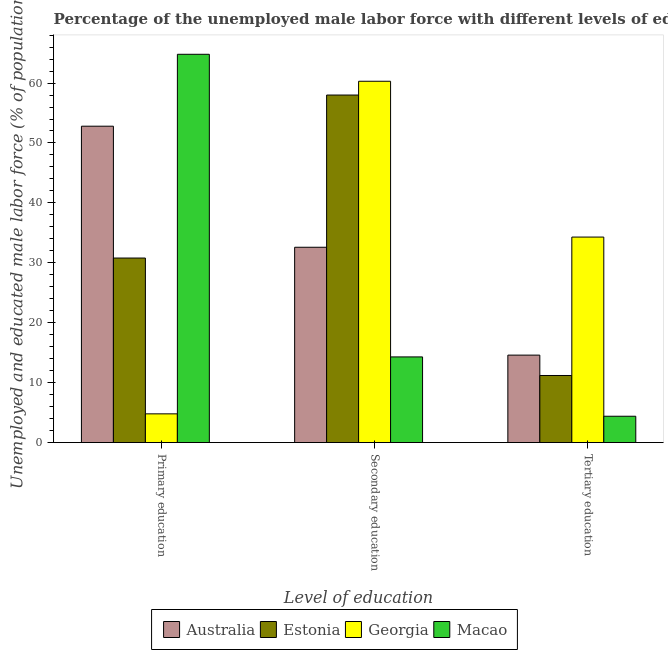How many different coloured bars are there?
Your answer should be compact. 4. Are the number of bars per tick equal to the number of legend labels?
Offer a very short reply. Yes. What is the label of the 2nd group of bars from the left?
Your answer should be very brief. Secondary education. What is the percentage of male labor force who received primary education in Macao?
Your response must be concise. 64.8. Across all countries, what is the maximum percentage of male labor force who received primary education?
Your response must be concise. 64.8. Across all countries, what is the minimum percentage of male labor force who received tertiary education?
Make the answer very short. 4.4. In which country was the percentage of male labor force who received tertiary education maximum?
Keep it short and to the point. Georgia. In which country was the percentage of male labor force who received tertiary education minimum?
Ensure brevity in your answer.  Macao. What is the total percentage of male labor force who received secondary education in the graph?
Keep it short and to the point. 165.2. What is the difference between the percentage of male labor force who received secondary education in Macao and that in Georgia?
Offer a very short reply. -46. What is the difference between the percentage of male labor force who received primary education in Georgia and the percentage of male labor force who received tertiary education in Macao?
Your response must be concise. 0.4. What is the average percentage of male labor force who received tertiary education per country?
Offer a very short reply. 16.12. What is the difference between the percentage of male labor force who received primary education and percentage of male labor force who received tertiary education in Georgia?
Offer a very short reply. -29.5. In how many countries, is the percentage of male labor force who received primary education greater than 40 %?
Give a very brief answer. 2. What is the ratio of the percentage of male labor force who received primary education in Estonia to that in Georgia?
Ensure brevity in your answer.  6.42. Is the difference between the percentage of male labor force who received primary education in Georgia and Macao greater than the difference between the percentage of male labor force who received tertiary education in Georgia and Macao?
Keep it short and to the point. No. What is the difference between the highest and the second highest percentage of male labor force who received secondary education?
Your answer should be very brief. 2.3. What is the difference between the highest and the lowest percentage of male labor force who received primary education?
Offer a terse response. 60. What does the 3rd bar from the left in Tertiary education represents?
Make the answer very short. Georgia. What does the 3rd bar from the right in Primary education represents?
Your answer should be compact. Estonia. Is it the case that in every country, the sum of the percentage of male labor force who received primary education and percentage of male labor force who received secondary education is greater than the percentage of male labor force who received tertiary education?
Make the answer very short. Yes. How many countries are there in the graph?
Make the answer very short. 4. What is the difference between two consecutive major ticks on the Y-axis?
Your answer should be very brief. 10. Are the values on the major ticks of Y-axis written in scientific E-notation?
Keep it short and to the point. No. Does the graph contain any zero values?
Make the answer very short. No. Where does the legend appear in the graph?
Your response must be concise. Bottom center. How many legend labels are there?
Make the answer very short. 4. What is the title of the graph?
Ensure brevity in your answer.  Percentage of the unemployed male labor force with different levels of education in countries. Does "Low income" appear as one of the legend labels in the graph?
Give a very brief answer. No. What is the label or title of the X-axis?
Provide a succinct answer. Level of education. What is the label or title of the Y-axis?
Provide a succinct answer. Unemployed and educated male labor force (% of population). What is the Unemployed and educated male labor force (% of population) of Australia in Primary education?
Offer a very short reply. 52.8. What is the Unemployed and educated male labor force (% of population) in Estonia in Primary education?
Offer a very short reply. 30.8. What is the Unemployed and educated male labor force (% of population) of Georgia in Primary education?
Your response must be concise. 4.8. What is the Unemployed and educated male labor force (% of population) of Macao in Primary education?
Offer a terse response. 64.8. What is the Unemployed and educated male labor force (% of population) in Australia in Secondary education?
Provide a short and direct response. 32.6. What is the Unemployed and educated male labor force (% of population) of Georgia in Secondary education?
Your answer should be very brief. 60.3. What is the Unemployed and educated male labor force (% of population) of Macao in Secondary education?
Give a very brief answer. 14.3. What is the Unemployed and educated male labor force (% of population) in Australia in Tertiary education?
Your response must be concise. 14.6. What is the Unemployed and educated male labor force (% of population) of Estonia in Tertiary education?
Ensure brevity in your answer.  11.2. What is the Unemployed and educated male labor force (% of population) of Georgia in Tertiary education?
Make the answer very short. 34.3. What is the Unemployed and educated male labor force (% of population) in Macao in Tertiary education?
Provide a short and direct response. 4.4. Across all Level of education, what is the maximum Unemployed and educated male labor force (% of population) in Australia?
Offer a terse response. 52.8. Across all Level of education, what is the maximum Unemployed and educated male labor force (% of population) of Georgia?
Give a very brief answer. 60.3. Across all Level of education, what is the maximum Unemployed and educated male labor force (% of population) of Macao?
Offer a terse response. 64.8. Across all Level of education, what is the minimum Unemployed and educated male labor force (% of population) in Australia?
Your response must be concise. 14.6. Across all Level of education, what is the minimum Unemployed and educated male labor force (% of population) in Estonia?
Ensure brevity in your answer.  11.2. Across all Level of education, what is the minimum Unemployed and educated male labor force (% of population) in Georgia?
Make the answer very short. 4.8. Across all Level of education, what is the minimum Unemployed and educated male labor force (% of population) of Macao?
Your answer should be compact. 4.4. What is the total Unemployed and educated male labor force (% of population) in Estonia in the graph?
Offer a terse response. 100. What is the total Unemployed and educated male labor force (% of population) in Georgia in the graph?
Offer a terse response. 99.4. What is the total Unemployed and educated male labor force (% of population) in Macao in the graph?
Provide a succinct answer. 83.5. What is the difference between the Unemployed and educated male labor force (% of population) in Australia in Primary education and that in Secondary education?
Give a very brief answer. 20.2. What is the difference between the Unemployed and educated male labor force (% of population) of Estonia in Primary education and that in Secondary education?
Make the answer very short. -27.2. What is the difference between the Unemployed and educated male labor force (% of population) of Georgia in Primary education and that in Secondary education?
Your answer should be compact. -55.5. What is the difference between the Unemployed and educated male labor force (% of population) of Macao in Primary education and that in Secondary education?
Your answer should be very brief. 50.5. What is the difference between the Unemployed and educated male labor force (% of population) in Australia in Primary education and that in Tertiary education?
Your answer should be very brief. 38.2. What is the difference between the Unemployed and educated male labor force (% of population) of Estonia in Primary education and that in Tertiary education?
Provide a succinct answer. 19.6. What is the difference between the Unemployed and educated male labor force (% of population) of Georgia in Primary education and that in Tertiary education?
Your answer should be compact. -29.5. What is the difference between the Unemployed and educated male labor force (% of population) of Macao in Primary education and that in Tertiary education?
Make the answer very short. 60.4. What is the difference between the Unemployed and educated male labor force (% of population) in Estonia in Secondary education and that in Tertiary education?
Give a very brief answer. 46.8. What is the difference between the Unemployed and educated male labor force (% of population) in Georgia in Secondary education and that in Tertiary education?
Offer a terse response. 26. What is the difference between the Unemployed and educated male labor force (% of population) in Australia in Primary education and the Unemployed and educated male labor force (% of population) in Macao in Secondary education?
Your answer should be very brief. 38.5. What is the difference between the Unemployed and educated male labor force (% of population) in Estonia in Primary education and the Unemployed and educated male labor force (% of population) in Georgia in Secondary education?
Provide a succinct answer. -29.5. What is the difference between the Unemployed and educated male labor force (% of population) of Georgia in Primary education and the Unemployed and educated male labor force (% of population) of Macao in Secondary education?
Ensure brevity in your answer.  -9.5. What is the difference between the Unemployed and educated male labor force (% of population) of Australia in Primary education and the Unemployed and educated male labor force (% of population) of Estonia in Tertiary education?
Offer a very short reply. 41.6. What is the difference between the Unemployed and educated male labor force (% of population) in Australia in Primary education and the Unemployed and educated male labor force (% of population) in Georgia in Tertiary education?
Provide a short and direct response. 18.5. What is the difference between the Unemployed and educated male labor force (% of population) in Australia in Primary education and the Unemployed and educated male labor force (% of population) in Macao in Tertiary education?
Provide a succinct answer. 48.4. What is the difference between the Unemployed and educated male labor force (% of population) of Estonia in Primary education and the Unemployed and educated male labor force (% of population) of Georgia in Tertiary education?
Your answer should be compact. -3.5. What is the difference between the Unemployed and educated male labor force (% of population) of Estonia in Primary education and the Unemployed and educated male labor force (% of population) of Macao in Tertiary education?
Ensure brevity in your answer.  26.4. What is the difference between the Unemployed and educated male labor force (% of population) in Australia in Secondary education and the Unemployed and educated male labor force (% of population) in Estonia in Tertiary education?
Give a very brief answer. 21.4. What is the difference between the Unemployed and educated male labor force (% of population) of Australia in Secondary education and the Unemployed and educated male labor force (% of population) of Macao in Tertiary education?
Offer a terse response. 28.2. What is the difference between the Unemployed and educated male labor force (% of population) in Estonia in Secondary education and the Unemployed and educated male labor force (% of population) in Georgia in Tertiary education?
Give a very brief answer. 23.7. What is the difference between the Unemployed and educated male labor force (% of population) in Estonia in Secondary education and the Unemployed and educated male labor force (% of population) in Macao in Tertiary education?
Ensure brevity in your answer.  53.6. What is the difference between the Unemployed and educated male labor force (% of population) in Georgia in Secondary education and the Unemployed and educated male labor force (% of population) in Macao in Tertiary education?
Keep it short and to the point. 55.9. What is the average Unemployed and educated male labor force (% of population) in Australia per Level of education?
Your response must be concise. 33.33. What is the average Unemployed and educated male labor force (% of population) in Estonia per Level of education?
Make the answer very short. 33.33. What is the average Unemployed and educated male labor force (% of population) of Georgia per Level of education?
Your answer should be compact. 33.13. What is the average Unemployed and educated male labor force (% of population) in Macao per Level of education?
Make the answer very short. 27.83. What is the difference between the Unemployed and educated male labor force (% of population) in Australia and Unemployed and educated male labor force (% of population) in Estonia in Primary education?
Provide a short and direct response. 22. What is the difference between the Unemployed and educated male labor force (% of population) of Estonia and Unemployed and educated male labor force (% of population) of Macao in Primary education?
Give a very brief answer. -34. What is the difference between the Unemployed and educated male labor force (% of population) in Georgia and Unemployed and educated male labor force (% of population) in Macao in Primary education?
Offer a terse response. -60. What is the difference between the Unemployed and educated male labor force (% of population) of Australia and Unemployed and educated male labor force (% of population) of Estonia in Secondary education?
Provide a succinct answer. -25.4. What is the difference between the Unemployed and educated male labor force (% of population) of Australia and Unemployed and educated male labor force (% of population) of Georgia in Secondary education?
Your answer should be compact. -27.7. What is the difference between the Unemployed and educated male labor force (% of population) of Estonia and Unemployed and educated male labor force (% of population) of Macao in Secondary education?
Provide a short and direct response. 43.7. What is the difference between the Unemployed and educated male labor force (% of population) in Australia and Unemployed and educated male labor force (% of population) in Estonia in Tertiary education?
Your response must be concise. 3.4. What is the difference between the Unemployed and educated male labor force (% of population) in Australia and Unemployed and educated male labor force (% of population) in Georgia in Tertiary education?
Offer a terse response. -19.7. What is the difference between the Unemployed and educated male labor force (% of population) of Australia and Unemployed and educated male labor force (% of population) of Macao in Tertiary education?
Ensure brevity in your answer.  10.2. What is the difference between the Unemployed and educated male labor force (% of population) of Estonia and Unemployed and educated male labor force (% of population) of Georgia in Tertiary education?
Keep it short and to the point. -23.1. What is the difference between the Unemployed and educated male labor force (% of population) in Estonia and Unemployed and educated male labor force (% of population) in Macao in Tertiary education?
Offer a terse response. 6.8. What is the difference between the Unemployed and educated male labor force (% of population) of Georgia and Unemployed and educated male labor force (% of population) of Macao in Tertiary education?
Keep it short and to the point. 29.9. What is the ratio of the Unemployed and educated male labor force (% of population) of Australia in Primary education to that in Secondary education?
Your response must be concise. 1.62. What is the ratio of the Unemployed and educated male labor force (% of population) of Estonia in Primary education to that in Secondary education?
Offer a very short reply. 0.53. What is the ratio of the Unemployed and educated male labor force (% of population) in Georgia in Primary education to that in Secondary education?
Your answer should be very brief. 0.08. What is the ratio of the Unemployed and educated male labor force (% of population) of Macao in Primary education to that in Secondary education?
Make the answer very short. 4.53. What is the ratio of the Unemployed and educated male labor force (% of population) of Australia in Primary education to that in Tertiary education?
Offer a terse response. 3.62. What is the ratio of the Unemployed and educated male labor force (% of population) of Estonia in Primary education to that in Tertiary education?
Offer a very short reply. 2.75. What is the ratio of the Unemployed and educated male labor force (% of population) in Georgia in Primary education to that in Tertiary education?
Give a very brief answer. 0.14. What is the ratio of the Unemployed and educated male labor force (% of population) of Macao in Primary education to that in Tertiary education?
Offer a terse response. 14.73. What is the ratio of the Unemployed and educated male labor force (% of population) in Australia in Secondary education to that in Tertiary education?
Keep it short and to the point. 2.23. What is the ratio of the Unemployed and educated male labor force (% of population) in Estonia in Secondary education to that in Tertiary education?
Offer a very short reply. 5.18. What is the ratio of the Unemployed and educated male labor force (% of population) of Georgia in Secondary education to that in Tertiary education?
Your answer should be compact. 1.76. What is the ratio of the Unemployed and educated male labor force (% of population) in Macao in Secondary education to that in Tertiary education?
Provide a short and direct response. 3.25. What is the difference between the highest and the second highest Unemployed and educated male labor force (% of population) in Australia?
Give a very brief answer. 20.2. What is the difference between the highest and the second highest Unemployed and educated male labor force (% of population) of Estonia?
Ensure brevity in your answer.  27.2. What is the difference between the highest and the second highest Unemployed and educated male labor force (% of population) of Macao?
Offer a very short reply. 50.5. What is the difference between the highest and the lowest Unemployed and educated male labor force (% of population) of Australia?
Give a very brief answer. 38.2. What is the difference between the highest and the lowest Unemployed and educated male labor force (% of population) in Estonia?
Make the answer very short. 46.8. What is the difference between the highest and the lowest Unemployed and educated male labor force (% of population) of Georgia?
Offer a terse response. 55.5. What is the difference between the highest and the lowest Unemployed and educated male labor force (% of population) of Macao?
Your answer should be compact. 60.4. 